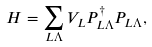Convert formula to latex. <formula><loc_0><loc_0><loc_500><loc_500>H = \sum _ { L \Lambda } V _ { L } P ^ { \dagger } _ { L \Lambda } P _ { L \Lambda } ,</formula> 